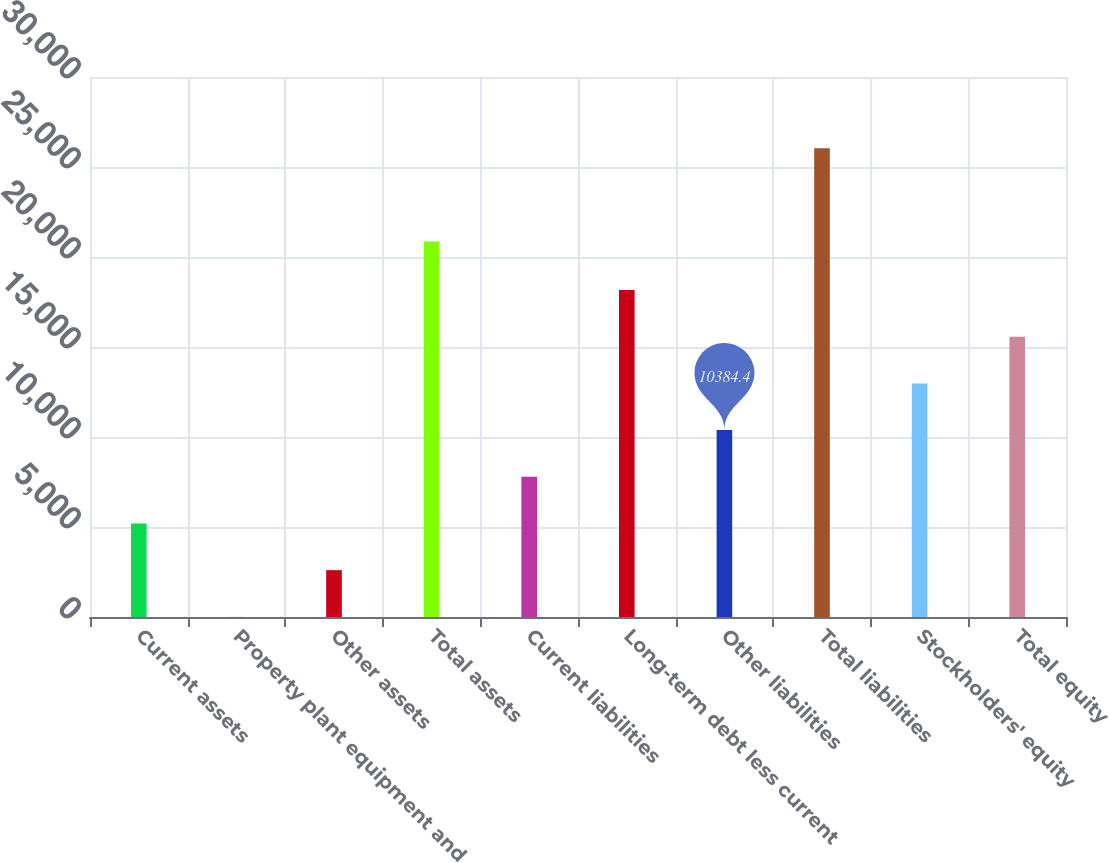Convert chart. <chart><loc_0><loc_0><loc_500><loc_500><bar_chart><fcel>Current assets<fcel>Property plant equipment and<fcel>Other assets<fcel>Total assets<fcel>Current liabilities<fcel>Long-term debt less current<fcel>Other liabilities<fcel>Total liabilities<fcel>Stockholders' equity<fcel>Total equity<nl><fcel>5197.2<fcel>10<fcel>2603.6<fcel>20861<fcel>7790.8<fcel>18165.2<fcel>10384.4<fcel>26048.2<fcel>12978<fcel>15571.6<nl></chart> 